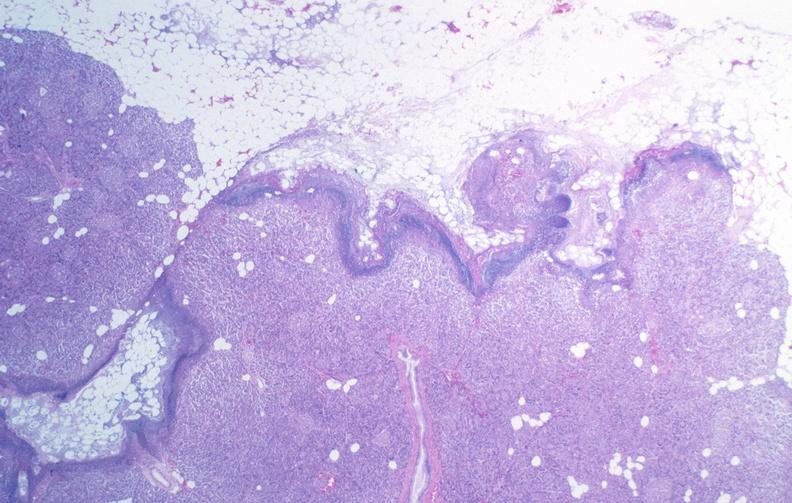does this image show pancreatic fat necrosis?
Answer the question using a single word or phrase. Yes 